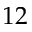<formula> <loc_0><loc_0><loc_500><loc_500>1 2</formula> 